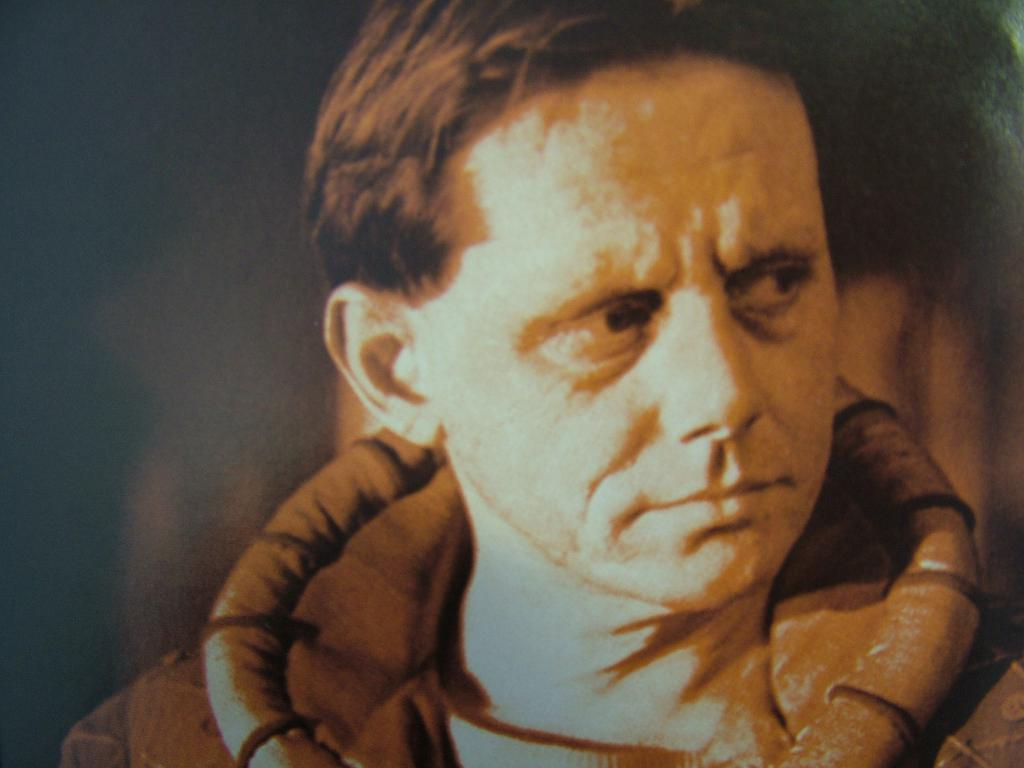What is the main subject of the image? There is a man in the image. What is the man wearing in the image? The man is wearing a jacket. Can you describe the background of the image? The background of the image is blurred. How many sticks can be seen in the image? There are no sticks present in the image. What type of home is visible in the background of the image? There is no home visible in the image, as the background is blurred. 